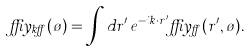<formula> <loc_0><loc_0><loc_500><loc_500>\delta y _ { { k } \alpha } ( \tau ) = \int d r ^ { \prime } \, e ^ { - i { k } \cdot r ^ { \prime } } \delta y _ { \alpha } ( r ^ { \prime } , \tau ) .</formula> 